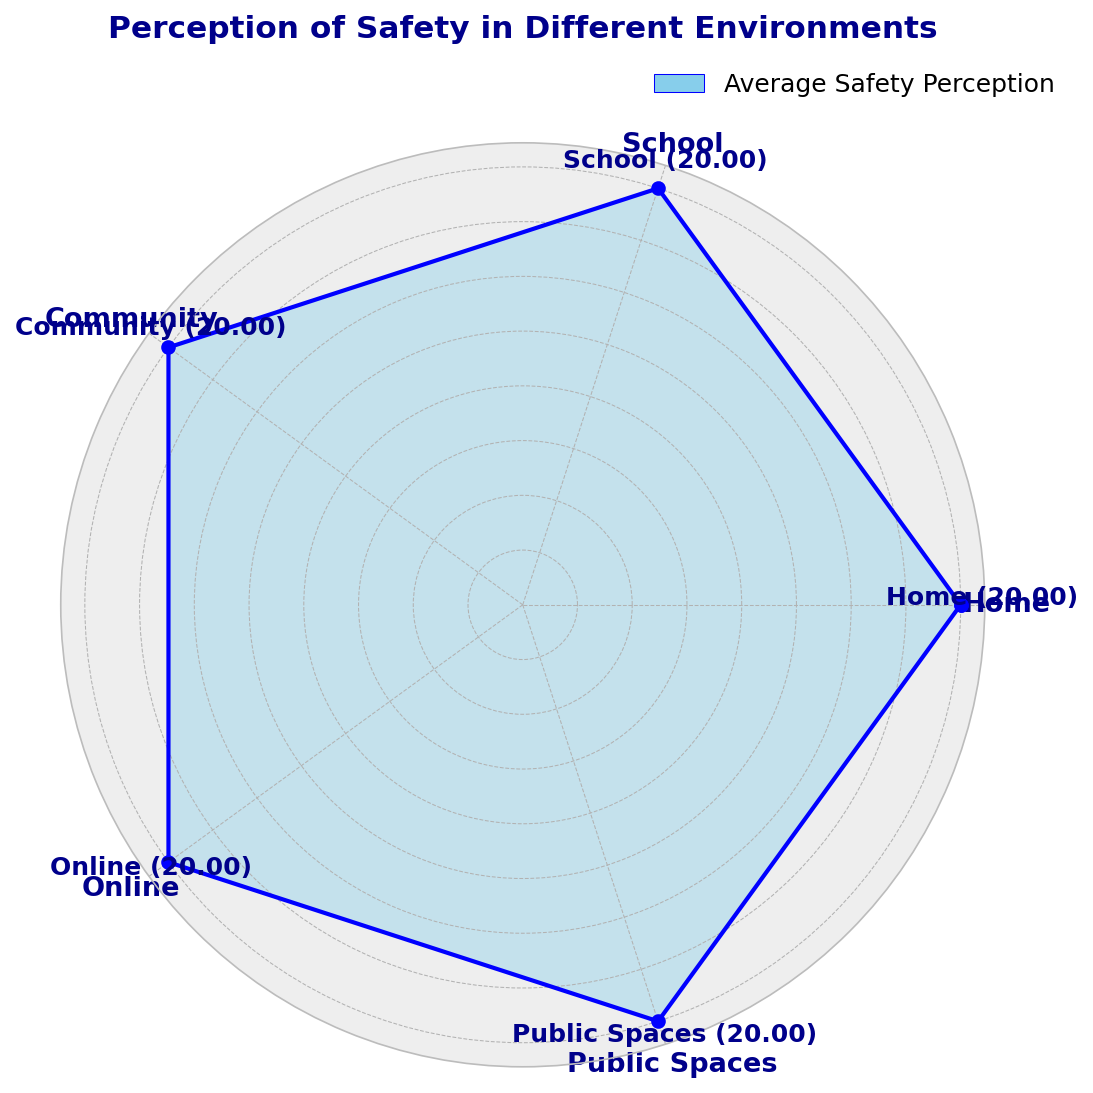Which environment is perceived as the safest? The chart shows average safety perceptions for different environments. The highest average value indicates the safest perception. The 'Home' category reaches the highest point on the radar chart.
Answer: Home Which environment is perceived as the least safe? To find this, look for the category that has the lowest average safety perception value on the chart. The 'Online' environment has the lowest value.
Answer: Online Rank the environments from safest to least safe. By examining the average safety values on the radar chart, we can order them from highest to lowest. The rank is Home, School, Community, Public Spaces, and Online.
Answer: Home, School, Community, Public Spaces, Online What is the average safety perception for Public Spaces? Locate the 'Public Spaces' category on the radar chart and read its average safety perception value which is visually displayed. The average safety perception value is around 20.
Answer: 20 Is the perceived safety in 'School' higher than in 'Public Spaces'? Compare the average values of 'School' and 'Public Spaces' on the chart. The 'School' environment has a higher average safety perception value than 'Public Spaces'.
Answer: Yes How does the safety perception in 'Community' compare to 'Online'? Compare the average safety values of 'Community' and 'Online' on the radar chart. The 'Community' environment has a higher average safety perception compared to 'Online'.
Answer: Community is perceived safer than Online What is the average safety value for 'School' and how does it compare to 'Home'? First, find the average safety perception value for 'School' on the chart. Then compare this value to that of 'Home'. 'School' has an average value lower than 'Home' but higher than several other environments.
Answer: School's average is lower than Home Which environment has the closest average safety perception to 'Public Spaces'? Referring to the radar chart, identify the environment whose average safety perception value is nearest to 'Public Spaces'. 'Community' has a value close to 'Public Spaces'.
Answer: Community Does any environment have a higher safety perception than 'Home'? Look for the category with an average value exceeding that of 'Home' on the radar chart. There is no environment with a higher average safety perception than 'Home'.
Answer: No Which environments have an average safety perception greater than or equal to 20? Examine the radar chart to find which environments have their safety perception values greater than or equal to 20. The environments are Home, School, Community, and Public Spaces.
Answer: Home, School, Community, Public Spaces 